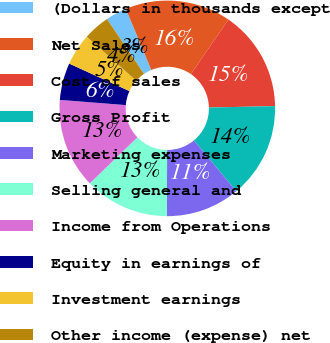Convert chart to OTSL. <chart><loc_0><loc_0><loc_500><loc_500><pie_chart><fcel>(Dollars in thousands except<fcel>Net Sales<fcel>Cost of sales<fcel>Gross Profit<fcel>Marketing expenses<fcel>Selling general and<fcel>Income from Operations<fcel>Equity in earnings of<fcel>Investment earnings<fcel>Other income (expense) net<nl><fcel>3.17%<fcel>15.87%<fcel>15.08%<fcel>14.29%<fcel>11.11%<fcel>12.7%<fcel>13.49%<fcel>5.56%<fcel>4.76%<fcel>3.97%<nl></chart> 